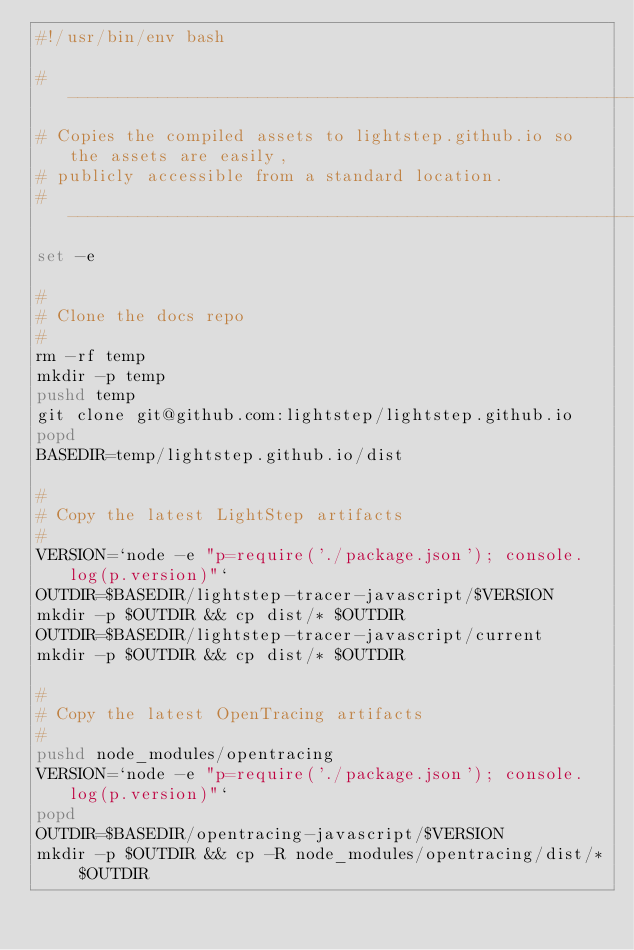<code> <loc_0><loc_0><loc_500><loc_500><_Bash_>#!/usr/bin/env bash

#-------------------------------------------------------------------------------
# Copies the compiled assets to lightstep.github.io so the assets are easily,
# publicly accessible from a standard location.
#-------------------------------------------------------------------------------
set -e

#
# Clone the docs repo
#
rm -rf temp
mkdir -p temp
pushd temp
git clone git@github.com:lightstep/lightstep.github.io
popd
BASEDIR=temp/lightstep.github.io/dist

#
# Copy the latest LightStep artifacts
#
VERSION=`node -e "p=require('./package.json'); console.log(p.version)"`
OUTDIR=$BASEDIR/lightstep-tracer-javascript/$VERSION
mkdir -p $OUTDIR && cp dist/* $OUTDIR
OUTDIR=$BASEDIR/lightstep-tracer-javascript/current
mkdir -p $OUTDIR && cp dist/* $OUTDIR

#
# Copy the latest OpenTracing artifacts
#
pushd node_modules/opentracing
VERSION=`node -e "p=require('./package.json'); console.log(p.version)"`
popd
OUTDIR=$BASEDIR/opentracing-javascript/$VERSION
mkdir -p $OUTDIR && cp -R node_modules/opentracing/dist/* $OUTDIR</code> 